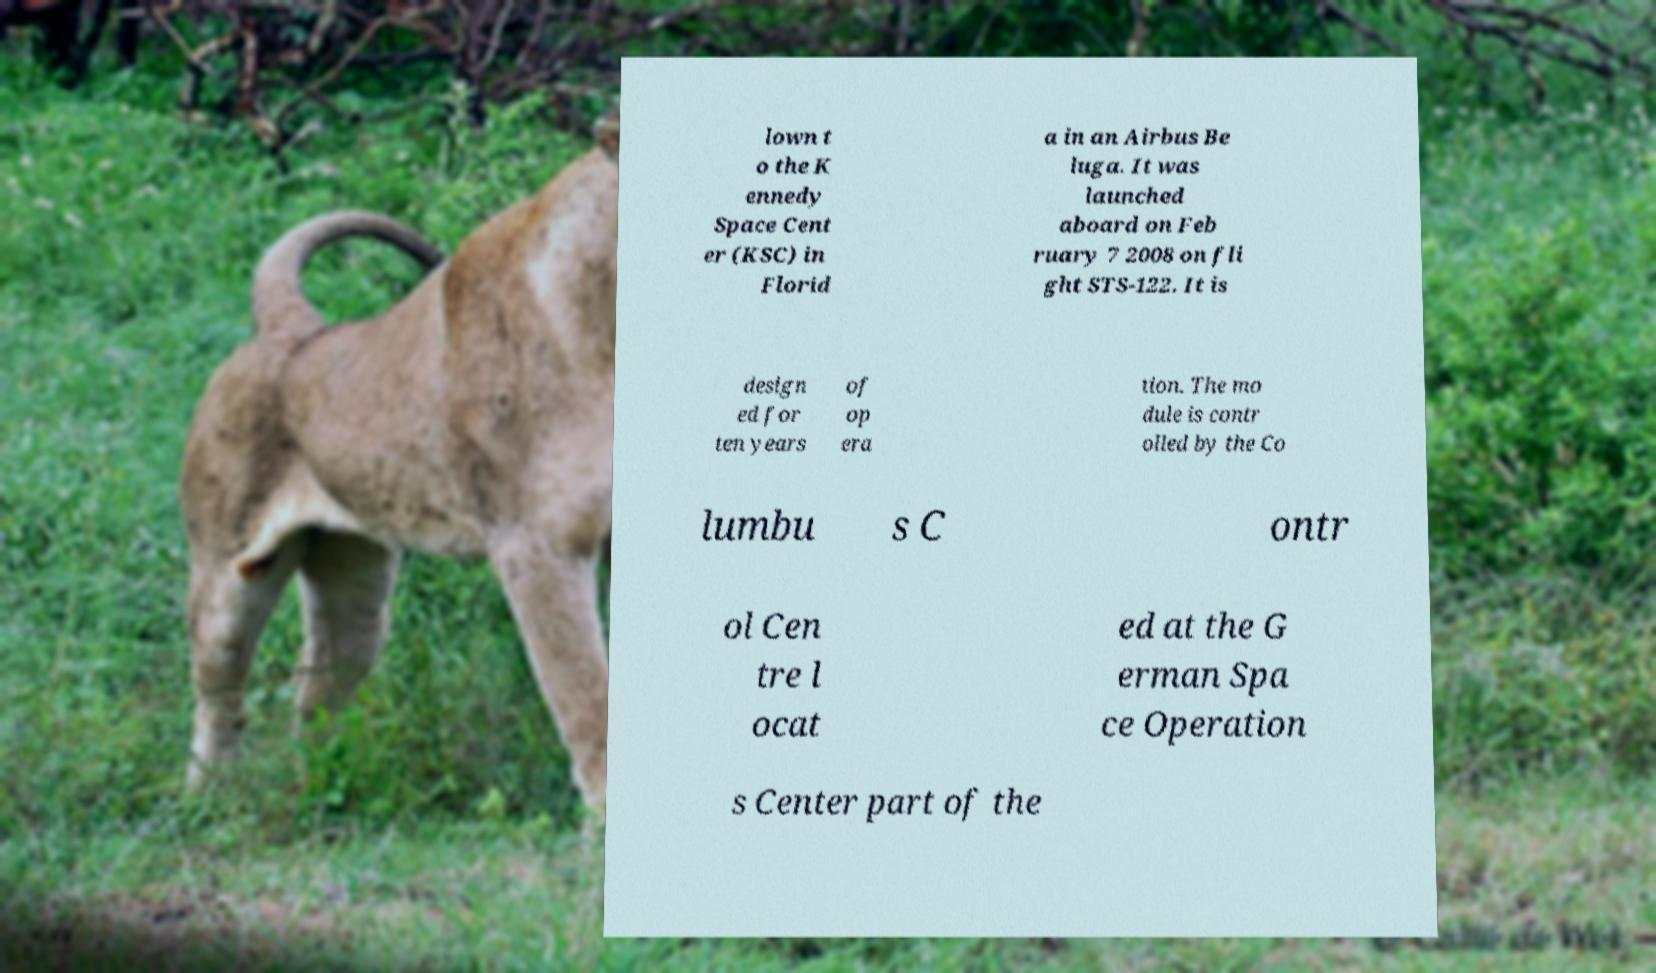Can you accurately transcribe the text from the provided image for me? lown t o the K ennedy Space Cent er (KSC) in Florid a in an Airbus Be luga. It was launched aboard on Feb ruary 7 2008 on fli ght STS-122. It is design ed for ten years of op era tion. The mo dule is contr olled by the Co lumbu s C ontr ol Cen tre l ocat ed at the G erman Spa ce Operation s Center part of the 